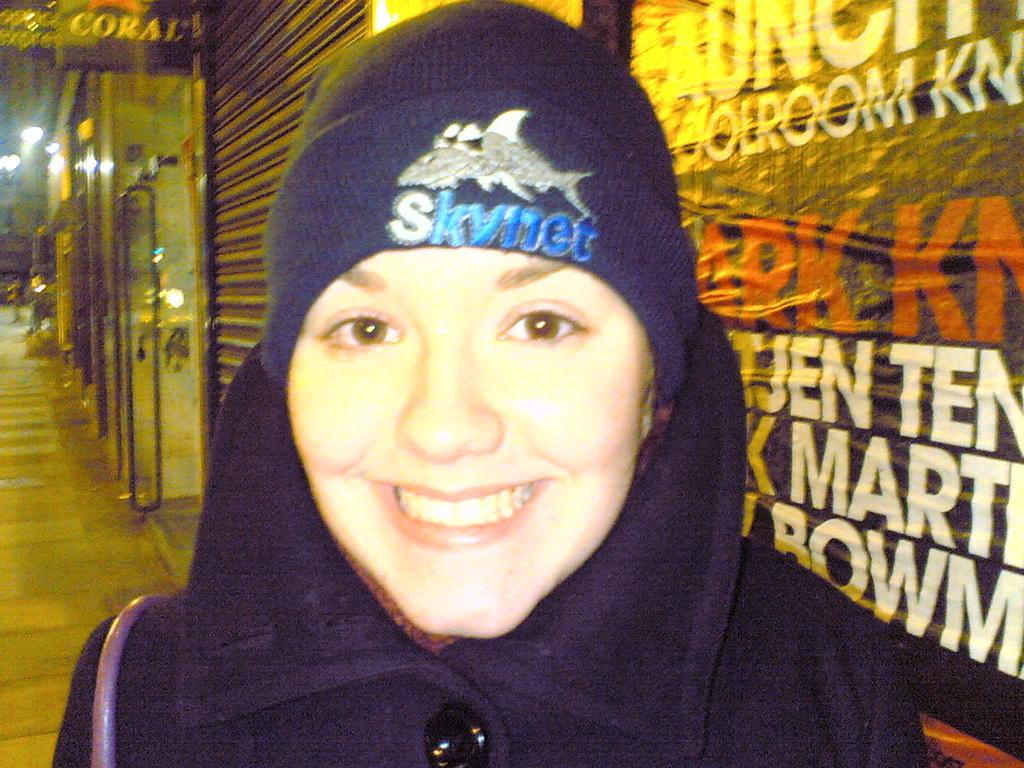Who is present in the image? There is a woman in the image. What is the woman wearing? The woman is wearing a black dress. What can be seen in the background of the image? There are shops in the background of the image. What is at the bottom of the image? There is a pavement at the bottom of the image. What is located to the right of the image? There is a banner to the right of the image. What month is it in the image? The month cannot be determined from the image, as there is no information about the time of year or any seasonal indicators present. 